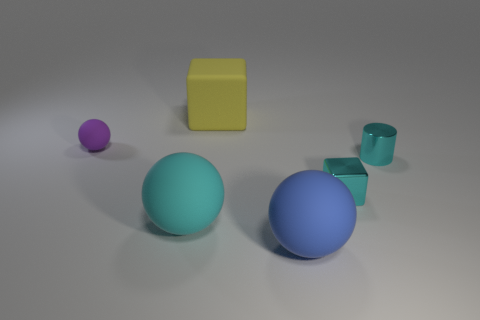Does the small object behind the small cylinder have the same color as the large matte sphere behind the blue rubber ball?
Your answer should be very brief. No. What is the shape of the cyan metal thing that is the same size as the cyan metal cube?
Make the answer very short. Cylinder. Is there a large blue shiny thing that has the same shape as the blue matte thing?
Provide a succinct answer. No. Does the tiny cyan thing that is on the left side of the small cylinder have the same material as the cyan cylinder that is to the right of the cyan rubber ball?
Your response must be concise. Yes. What shape is the rubber object that is the same color as the tiny metal block?
Offer a very short reply. Sphere. How many other small cyan cylinders have the same material as the cylinder?
Give a very brief answer. 0. The small rubber thing is what color?
Make the answer very short. Purple. Is the shape of the cyan thing that is to the left of the large blue matte sphere the same as the small object behind the small cyan shiny cylinder?
Provide a succinct answer. Yes. The block to the right of the blue sphere is what color?
Your answer should be very brief. Cyan. Are there fewer yellow rubber cubes behind the big yellow rubber cube than large matte things on the right side of the tiny purple matte object?
Ensure brevity in your answer.  Yes. 